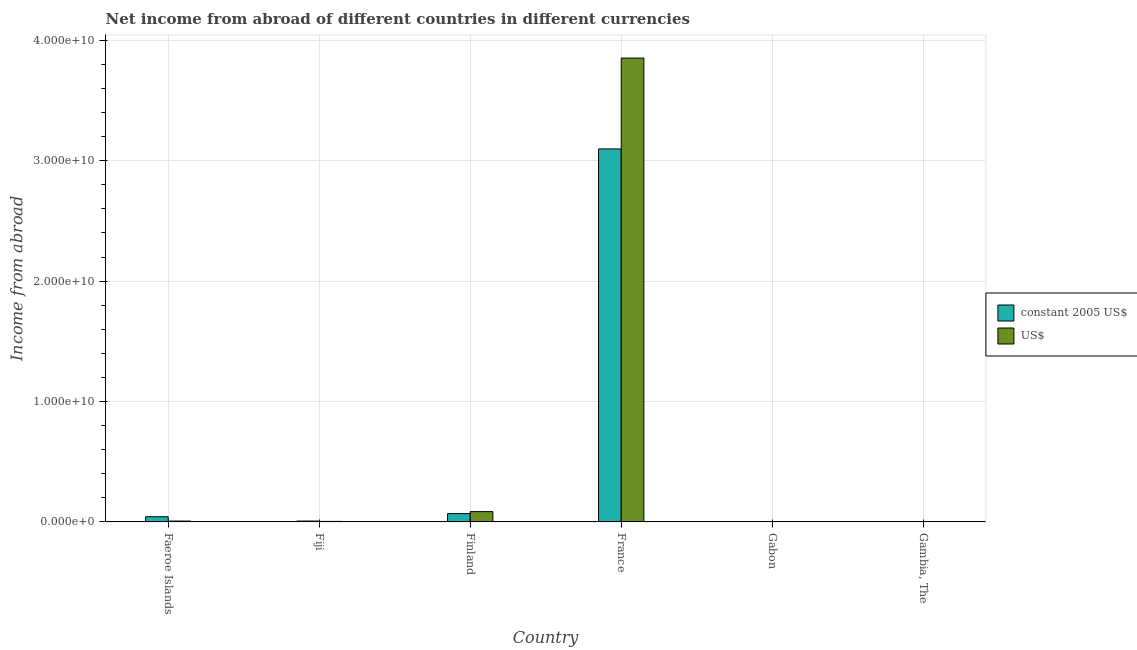How many different coloured bars are there?
Ensure brevity in your answer.  2. Are the number of bars per tick equal to the number of legend labels?
Offer a very short reply. No. What is the label of the 3rd group of bars from the left?
Your answer should be compact. Finland. What is the income from abroad in us$ in Finland?
Keep it short and to the point. 8.56e+08. Across all countries, what is the maximum income from abroad in constant 2005 us$?
Your answer should be compact. 3.10e+1. Across all countries, what is the minimum income from abroad in us$?
Give a very brief answer. 0. What is the total income from abroad in us$ in the graph?
Your answer should be compact. 3.95e+1. What is the difference between the income from abroad in constant 2005 us$ in Fiji and that in Finland?
Give a very brief answer. -6.15e+08. What is the difference between the income from abroad in us$ in Fiji and the income from abroad in constant 2005 us$ in Gambia, The?
Provide a succinct answer. 4.33e+07. What is the average income from abroad in us$ per country?
Offer a terse response. 6.58e+09. What is the difference between the income from abroad in constant 2005 us$ and income from abroad in us$ in Fiji?
Keep it short and to the point. 3.00e+07. What is the ratio of the income from abroad in us$ in Fiji to that in France?
Offer a very short reply. 0. Is the difference between the income from abroad in constant 2005 us$ in Finland and France greater than the difference between the income from abroad in us$ in Finland and France?
Provide a succinct answer. Yes. What is the difference between the highest and the second highest income from abroad in us$?
Ensure brevity in your answer.  3.77e+1. What is the difference between the highest and the lowest income from abroad in us$?
Your response must be concise. 3.85e+1. In how many countries, is the income from abroad in us$ greater than the average income from abroad in us$ taken over all countries?
Your response must be concise. 1. How many bars are there?
Your response must be concise. 8. Are all the bars in the graph horizontal?
Keep it short and to the point. No. How many countries are there in the graph?
Your answer should be very brief. 6. Does the graph contain any zero values?
Give a very brief answer. Yes. How many legend labels are there?
Offer a very short reply. 2. What is the title of the graph?
Give a very brief answer. Net income from abroad of different countries in different currencies. What is the label or title of the X-axis?
Offer a very short reply. Country. What is the label or title of the Y-axis?
Provide a succinct answer. Income from abroad. What is the Income from abroad of constant 2005 US$ in Faeroe Islands?
Ensure brevity in your answer.  4.31e+08. What is the Income from abroad of US$ in Faeroe Islands?
Make the answer very short. 7.19e+07. What is the Income from abroad of constant 2005 US$ in Fiji?
Your answer should be compact. 7.33e+07. What is the Income from abroad in US$ in Fiji?
Give a very brief answer. 4.33e+07. What is the Income from abroad in constant 2005 US$ in Finland?
Your response must be concise. 6.88e+08. What is the Income from abroad in US$ in Finland?
Your response must be concise. 8.56e+08. What is the Income from abroad of constant 2005 US$ in France?
Your answer should be compact. 3.10e+1. What is the Income from abroad in US$ in France?
Make the answer very short. 3.85e+1. What is the Income from abroad in constant 2005 US$ in Gabon?
Your answer should be compact. 0. What is the Income from abroad of US$ in Gabon?
Your answer should be compact. 0. What is the Income from abroad of constant 2005 US$ in Gambia, The?
Provide a succinct answer. 0. What is the Income from abroad in US$ in Gambia, The?
Make the answer very short. 0. Across all countries, what is the maximum Income from abroad in constant 2005 US$?
Provide a succinct answer. 3.10e+1. Across all countries, what is the maximum Income from abroad in US$?
Offer a very short reply. 3.85e+1. Across all countries, what is the minimum Income from abroad of constant 2005 US$?
Offer a very short reply. 0. What is the total Income from abroad in constant 2005 US$ in the graph?
Offer a terse response. 3.22e+1. What is the total Income from abroad in US$ in the graph?
Your answer should be compact. 3.95e+1. What is the difference between the Income from abroad in constant 2005 US$ in Faeroe Islands and that in Fiji?
Offer a terse response. 3.58e+08. What is the difference between the Income from abroad in US$ in Faeroe Islands and that in Fiji?
Give a very brief answer. 2.85e+07. What is the difference between the Income from abroad of constant 2005 US$ in Faeroe Islands and that in Finland?
Your response must be concise. -2.57e+08. What is the difference between the Income from abroad of US$ in Faeroe Islands and that in Finland?
Your response must be concise. -7.84e+08. What is the difference between the Income from abroad of constant 2005 US$ in Faeroe Islands and that in France?
Your response must be concise. -3.06e+1. What is the difference between the Income from abroad in US$ in Faeroe Islands and that in France?
Your answer should be very brief. -3.85e+1. What is the difference between the Income from abroad in constant 2005 US$ in Fiji and that in Finland?
Offer a terse response. -6.15e+08. What is the difference between the Income from abroad of US$ in Fiji and that in Finland?
Give a very brief answer. -8.12e+08. What is the difference between the Income from abroad in constant 2005 US$ in Fiji and that in France?
Give a very brief answer. -3.09e+1. What is the difference between the Income from abroad in US$ in Fiji and that in France?
Provide a short and direct response. -3.85e+1. What is the difference between the Income from abroad in constant 2005 US$ in Finland and that in France?
Keep it short and to the point. -3.03e+1. What is the difference between the Income from abroad in US$ in Finland and that in France?
Offer a very short reply. -3.77e+1. What is the difference between the Income from abroad in constant 2005 US$ in Faeroe Islands and the Income from abroad in US$ in Fiji?
Keep it short and to the point. 3.88e+08. What is the difference between the Income from abroad of constant 2005 US$ in Faeroe Islands and the Income from abroad of US$ in Finland?
Provide a succinct answer. -4.25e+08. What is the difference between the Income from abroad in constant 2005 US$ in Faeroe Islands and the Income from abroad in US$ in France?
Provide a short and direct response. -3.81e+1. What is the difference between the Income from abroad in constant 2005 US$ in Fiji and the Income from abroad in US$ in Finland?
Ensure brevity in your answer.  -7.82e+08. What is the difference between the Income from abroad of constant 2005 US$ in Fiji and the Income from abroad of US$ in France?
Your response must be concise. -3.85e+1. What is the difference between the Income from abroad in constant 2005 US$ in Finland and the Income from abroad in US$ in France?
Your answer should be very brief. -3.78e+1. What is the average Income from abroad in constant 2005 US$ per country?
Ensure brevity in your answer.  5.36e+09. What is the average Income from abroad of US$ per country?
Offer a very short reply. 6.58e+09. What is the difference between the Income from abroad in constant 2005 US$ and Income from abroad in US$ in Faeroe Islands?
Provide a succinct answer. 3.59e+08. What is the difference between the Income from abroad in constant 2005 US$ and Income from abroad in US$ in Fiji?
Ensure brevity in your answer.  3.00e+07. What is the difference between the Income from abroad of constant 2005 US$ and Income from abroad of US$ in Finland?
Offer a terse response. -1.68e+08. What is the difference between the Income from abroad in constant 2005 US$ and Income from abroad in US$ in France?
Provide a short and direct response. -7.55e+09. What is the ratio of the Income from abroad in constant 2005 US$ in Faeroe Islands to that in Fiji?
Give a very brief answer. 5.88. What is the ratio of the Income from abroad in US$ in Faeroe Islands to that in Fiji?
Keep it short and to the point. 1.66. What is the ratio of the Income from abroad of constant 2005 US$ in Faeroe Islands to that in Finland?
Your answer should be compact. 0.63. What is the ratio of the Income from abroad of US$ in Faeroe Islands to that in Finland?
Make the answer very short. 0.08. What is the ratio of the Income from abroad of constant 2005 US$ in Faeroe Islands to that in France?
Offer a terse response. 0.01. What is the ratio of the Income from abroad of US$ in Faeroe Islands to that in France?
Your answer should be very brief. 0. What is the ratio of the Income from abroad of constant 2005 US$ in Fiji to that in Finland?
Make the answer very short. 0.11. What is the ratio of the Income from abroad in US$ in Fiji to that in Finland?
Make the answer very short. 0.05. What is the ratio of the Income from abroad in constant 2005 US$ in Fiji to that in France?
Offer a terse response. 0. What is the ratio of the Income from abroad of US$ in Fiji to that in France?
Offer a terse response. 0. What is the ratio of the Income from abroad of constant 2005 US$ in Finland to that in France?
Your answer should be very brief. 0.02. What is the ratio of the Income from abroad of US$ in Finland to that in France?
Ensure brevity in your answer.  0.02. What is the difference between the highest and the second highest Income from abroad in constant 2005 US$?
Your answer should be very brief. 3.03e+1. What is the difference between the highest and the second highest Income from abroad of US$?
Give a very brief answer. 3.77e+1. What is the difference between the highest and the lowest Income from abroad of constant 2005 US$?
Your answer should be very brief. 3.10e+1. What is the difference between the highest and the lowest Income from abroad in US$?
Provide a short and direct response. 3.85e+1. 